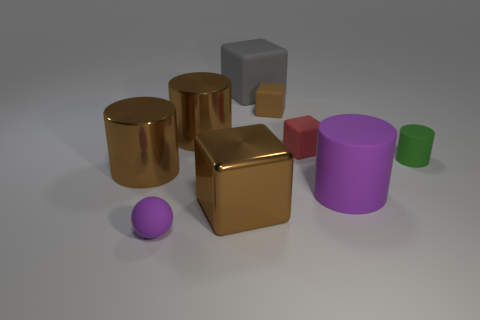Is the cylinder to the left of the purple sphere made of the same material as the tiny sphere?
Offer a terse response. No. There is a cylinder left of the small purple thing; what material is it?
Ensure brevity in your answer.  Metal. There is a purple matte thing in front of the big brown thing that is in front of the purple cylinder; what size is it?
Offer a very short reply. Small. What number of brown metallic cylinders are the same size as the green rubber cylinder?
Your answer should be compact. 0. Does the big cube in front of the tiny green thing have the same color as the shiny cylinder in front of the green matte cylinder?
Ensure brevity in your answer.  Yes. There is a rubber ball; are there any small rubber cylinders in front of it?
Give a very brief answer. No. The rubber object that is behind the tiny green cylinder and left of the brown rubber cube is what color?
Keep it short and to the point. Gray. Are there any small rubber cylinders that have the same color as the small matte ball?
Provide a succinct answer. No. Does the brown block to the left of the gray thing have the same material as the brown thing right of the gray rubber thing?
Make the answer very short. No. There is a metallic object behind the tiny green thing; what size is it?
Your answer should be very brief. Large. 